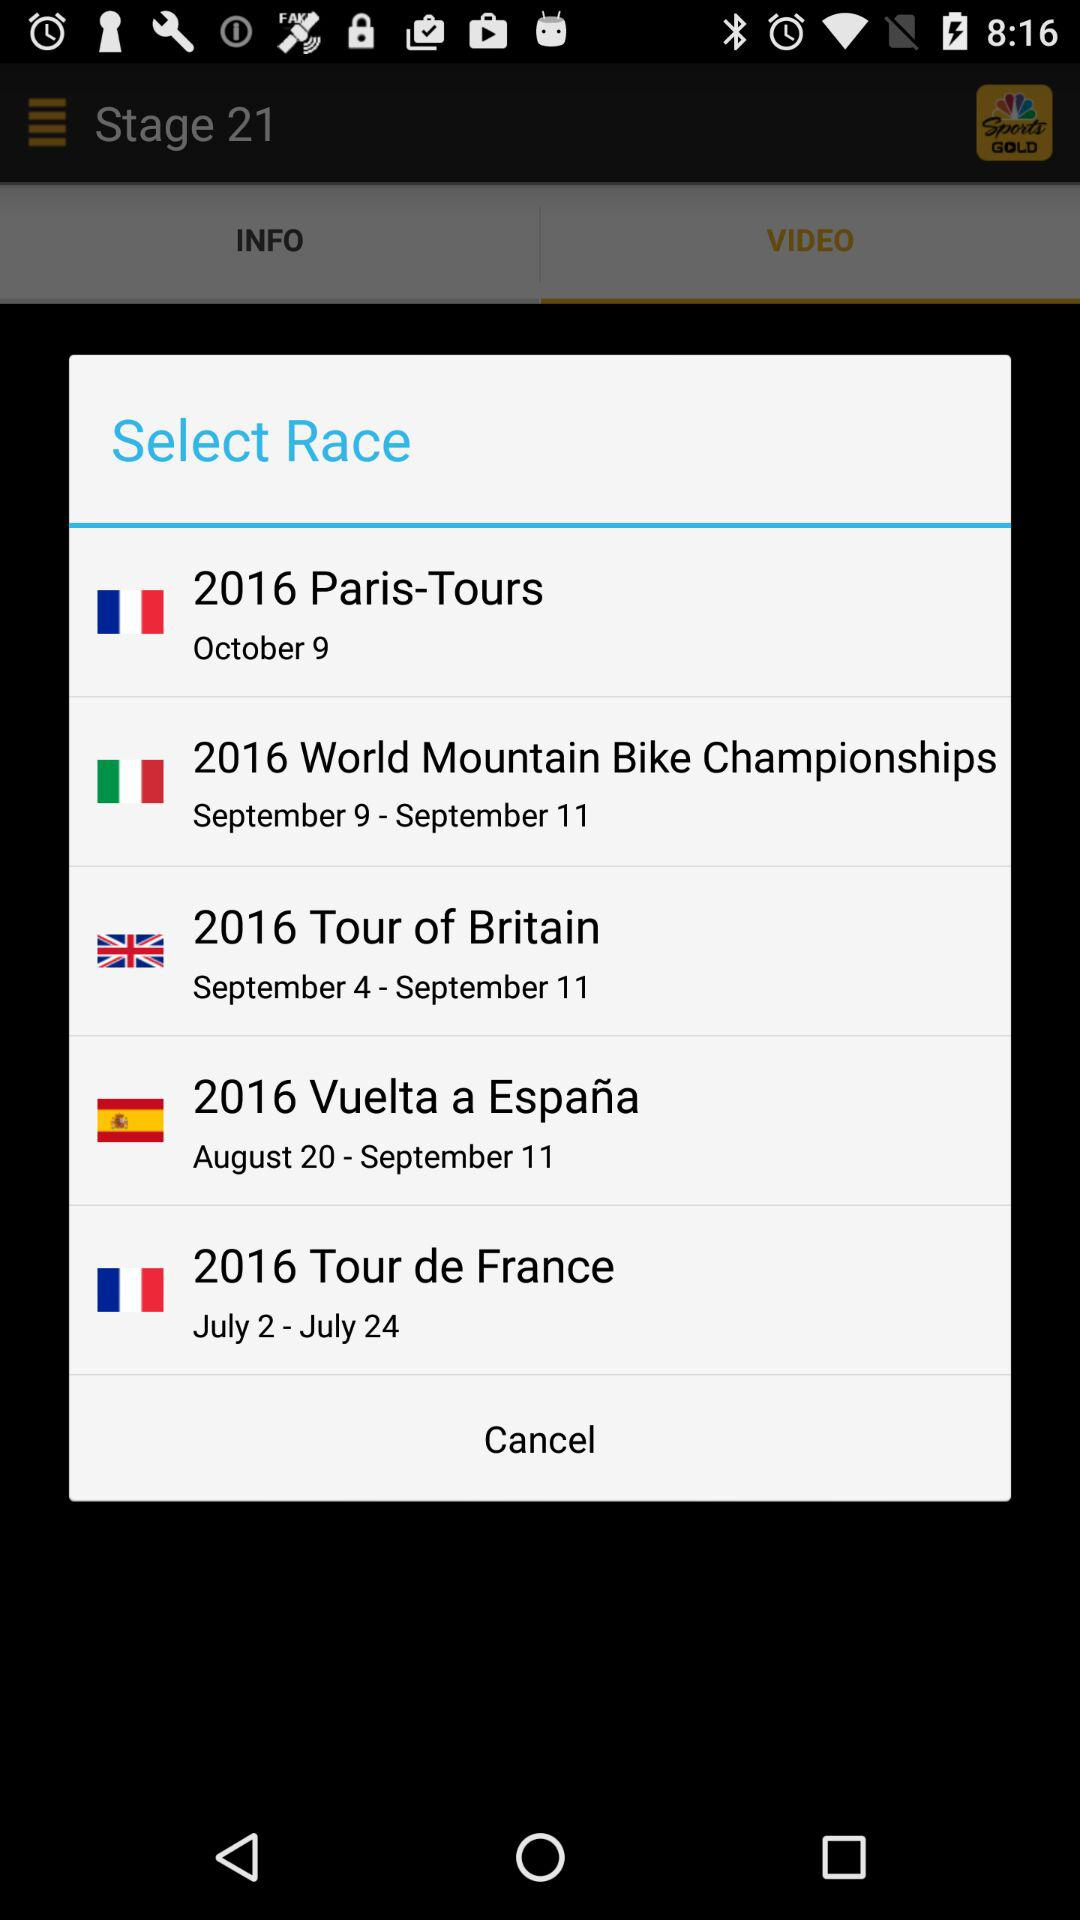How many races are there?
Answer the question using a single word or phrase. 5 